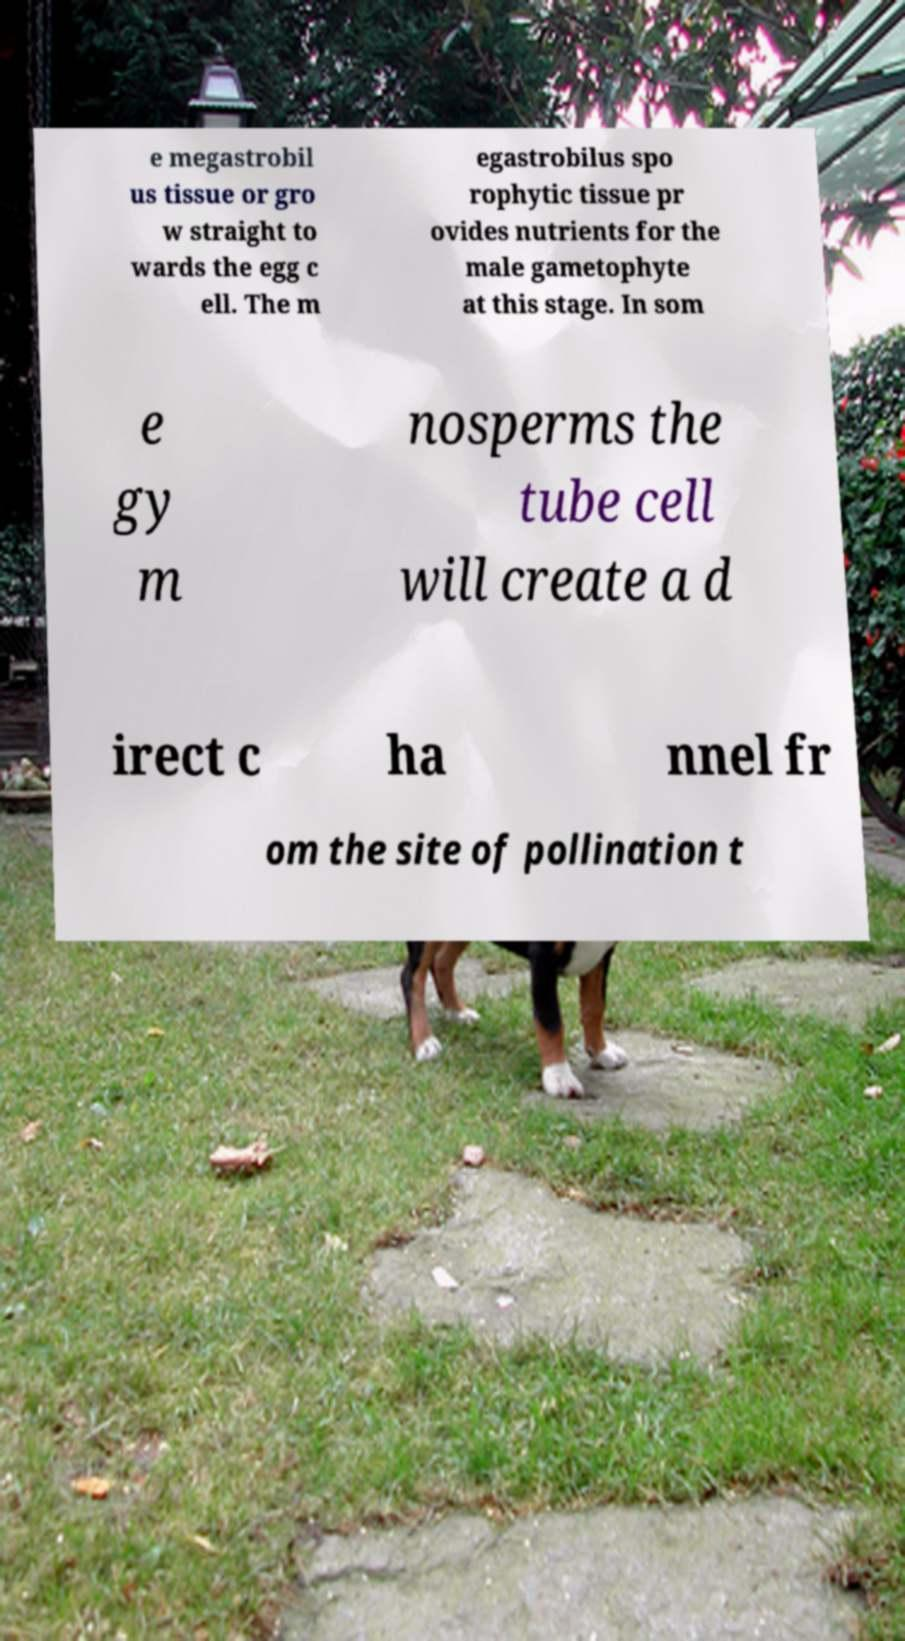For documentation purposes, I need the text within this image transcribed. Could you provide that? e megastrobil us tissue or gro w straight to wards the egg c ell. The m egastrobilus spo rophytic tissue pr ovides nutrients for the male gametophyte at this stage. In som e gy m nosperms the tube cell will create a d irect c ha nnel fr om the site of pollination t 